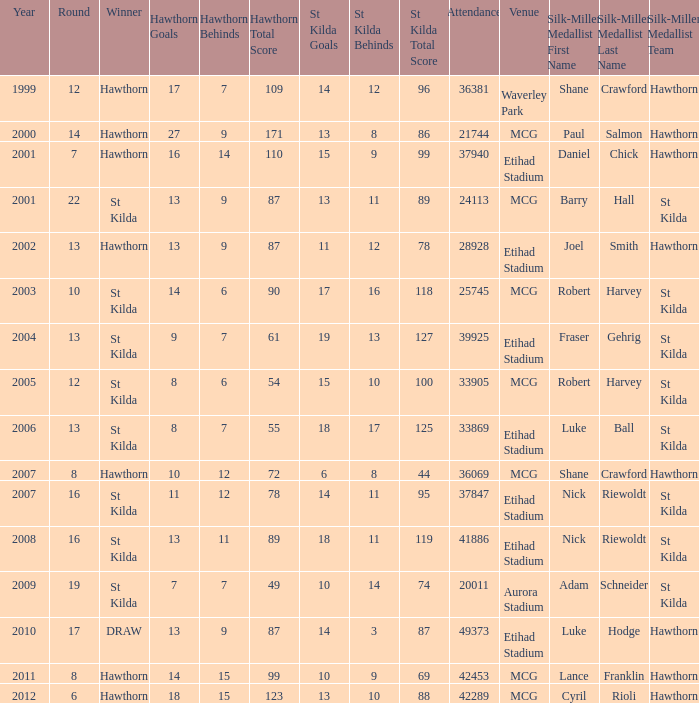Who is the winner when the st kilda score is 13.10.88? Hawthorn. 